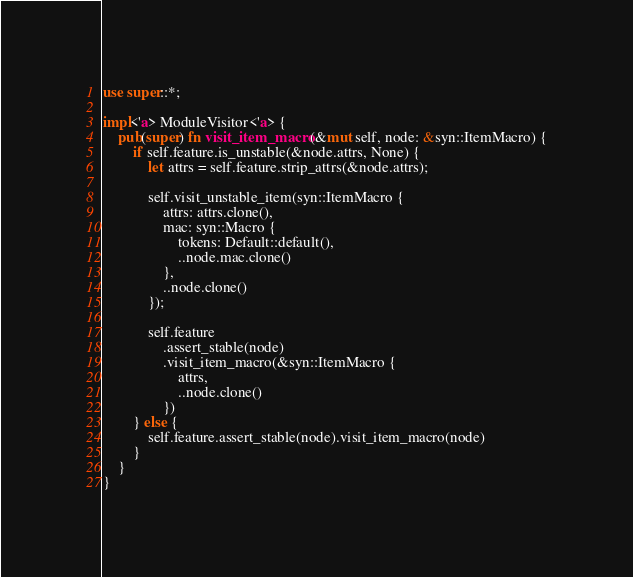<code> <loc_0><loc_0><loc_500><loc_500><_Rust_>use super::*;

impl<'a> ModuleVisitor<'a> {
    pub(super) fn visit_item_macro(&mut self, node: &syn::ItemMacro) {
        if self.feature.is_unstable(&node.attrs, None) {
            let attrs = self.feature.strip_attrs(&node.attrs);

            self.visit_unstable_item(syn::ItemMacro {
                attrs: attrs.clone(),
                mac: syn::Macro {
                    tokens: Default::default(),
                    ..node.mac.clone()
                },
                ..node.clone()
            });

            self.feature
                .assert_stable(node)
                .visit_item_macro(&syn::ItemMacro {
                    attrs,
                    ..node.clone()
                })
        } else {
            self.feature.assert_stable(node).visit_item_macro(node)
        }
    }
}
</code> 